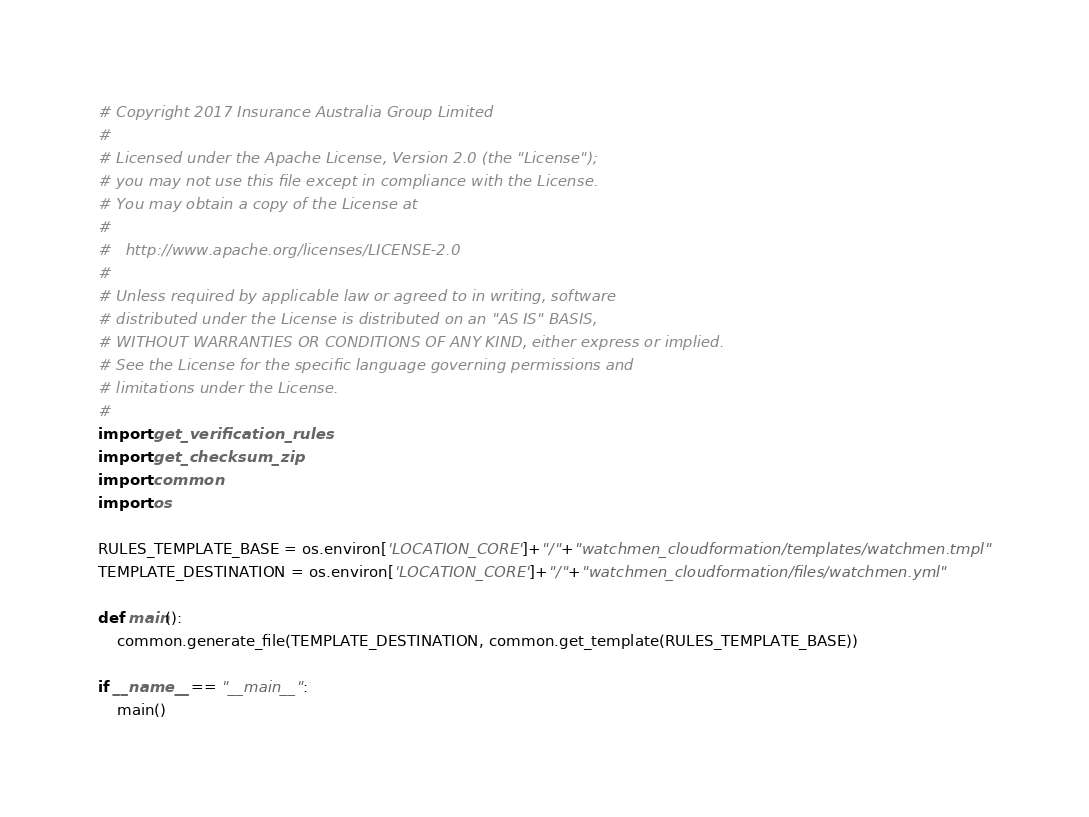<code> <loc_0><loc_0><loc_500><loc_500><_Python_># Copyright 2017 Insurance Australia Group Limited
#
# Licensed under the Apache License, Version 2.0 (the "License");
# you may not use this file except in compliance with the License.
# You may obtain a copy of the License at
#
#   http://www.apache.org/licenses/LICENSE-2.0
#
# Unless required by applicable law or agreed to in writing, software
# distributed under the License is distributed on an "AS IS" BASIS,
# WITHOUT WARRANTIES OR CONDITIONS OF ANY KIND, either express or implied.
# See the License for the specific language governing permissions and
# limitations under the License.
#
import get_verification_rules
import get_checksum_zip
import common
import os

RULES_TEMPLATE_BASE = os.environ['LOCATION_CORE']+"/"+"watchmen_cloudformation/templates/watchmen.tmpl"
TEMPLATE_DESTINATION = os.environ['LOCATION_CORE']+"/"+"watchmen_cloudformation/files/watchmen.yml"

def main():
    common.generate_file(TEMPLATE_DESTINATION, common.get_template(RULES_TEMPLATE_BASE))

if __name__ == "__main__":
    main()
</code> 